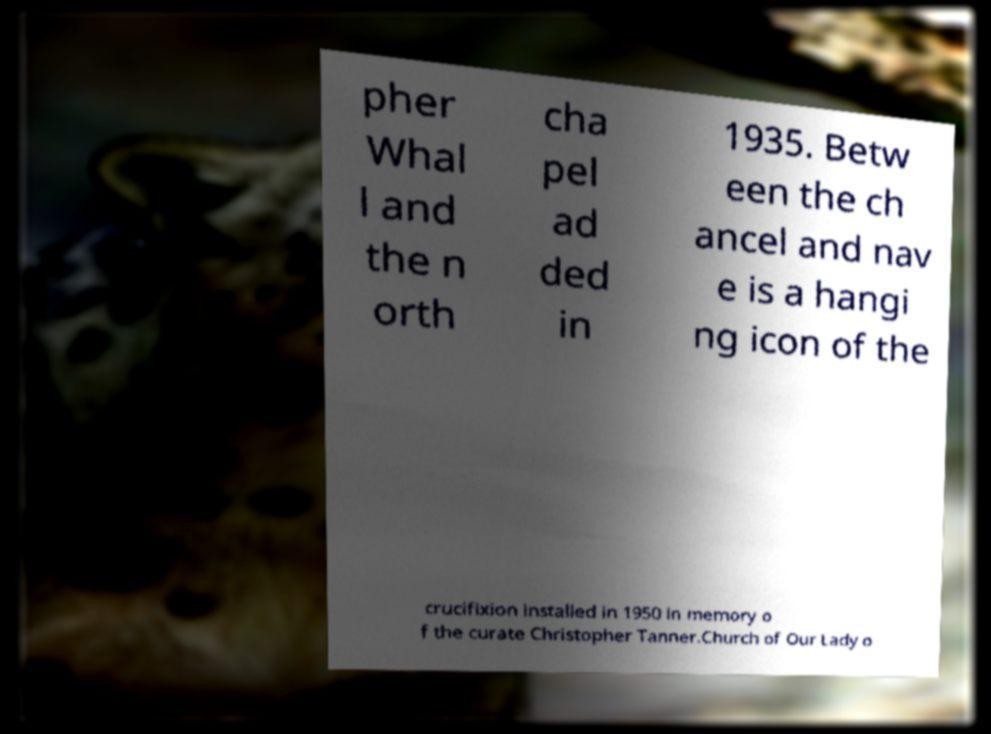Could you assist in decoding the text presented in this image and type it out clearly? pher Whal l and the n orth cha pel ad ded in 1935. Betw een the ch ancel and nav e is a hangi ng icon of the crucifixion installed in 1950 in memory o f the curate Christopher Tanner.Church of Our Lady o 